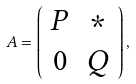<formula> <loc_0><loc_0><loc_500><loc_500>A = \left ( \begin{array} { c c } P & * \\ 0 & Q \end{array} \right ) ,</formula> 